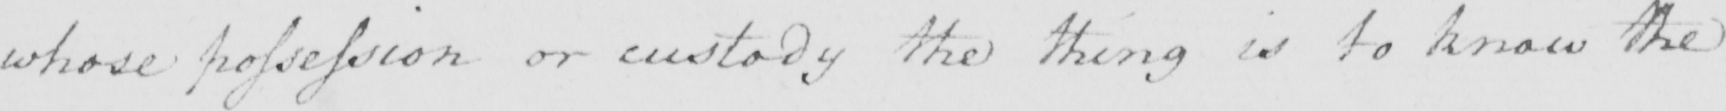Can you tell me what this handwritten text says? whose possession or custody the thing is to know the 